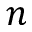<formula> <loc_0><loc_0><loc_500><loc_500>n</formula> 